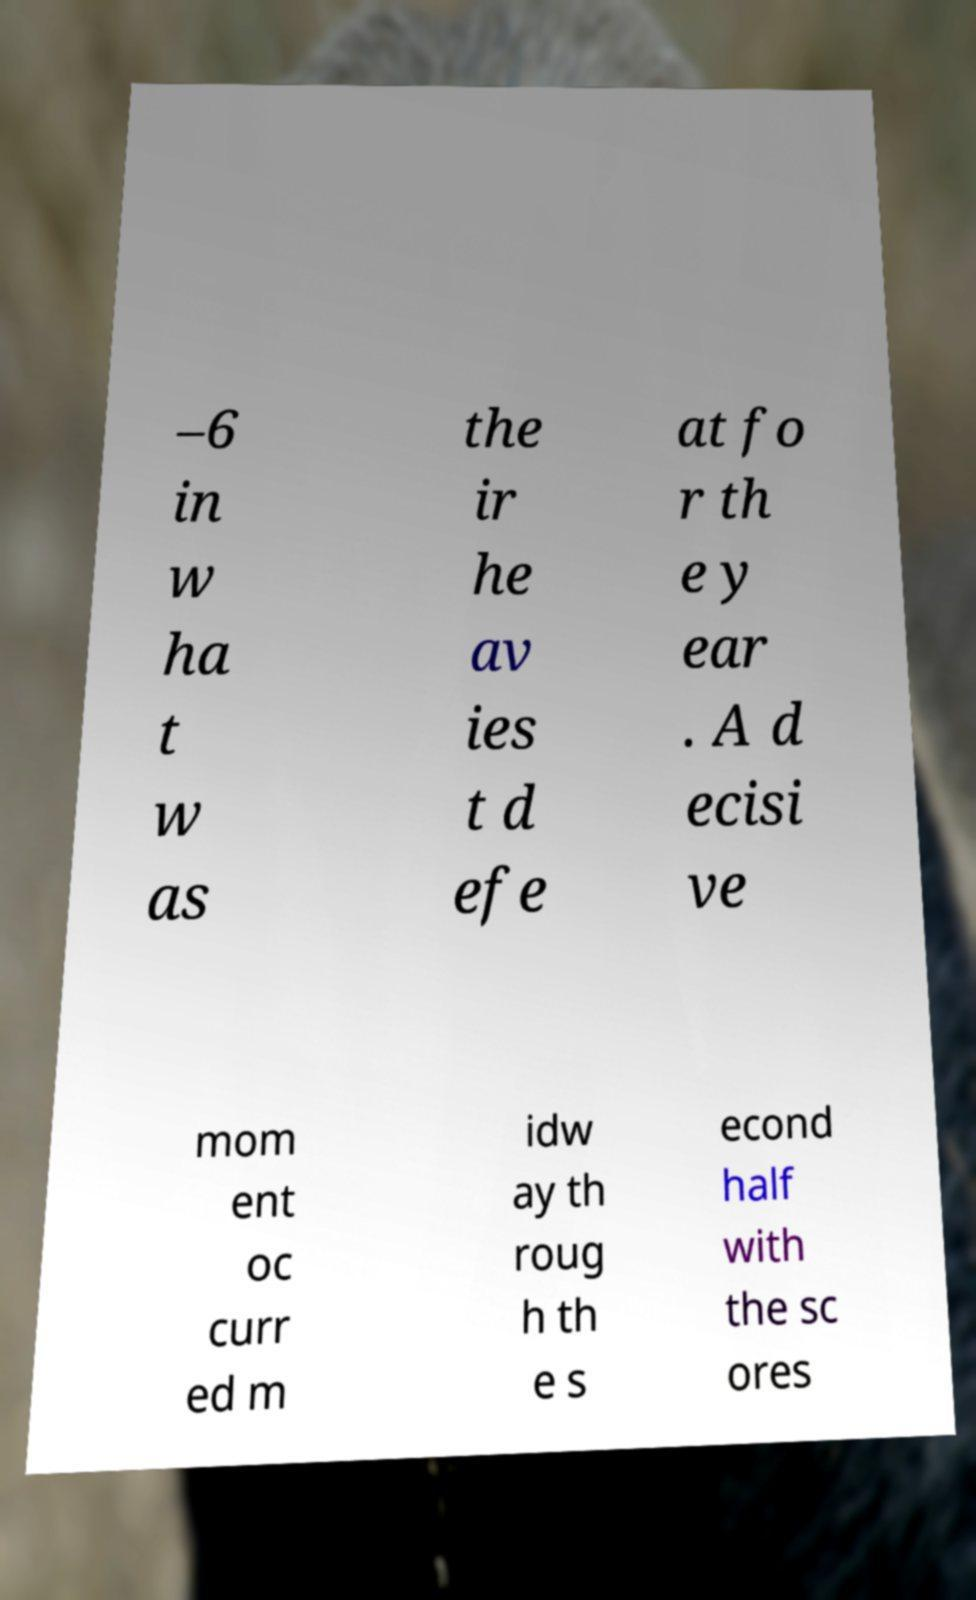Could you assist in decoding the text presented in this image and type it out clearly? –6 in w ha t w as the ir he av ies t d efe at fo r th e y ear . A d ecisi ve mom ent oc curr ed m idw ay th roug h th e s econd half with the sc ores 